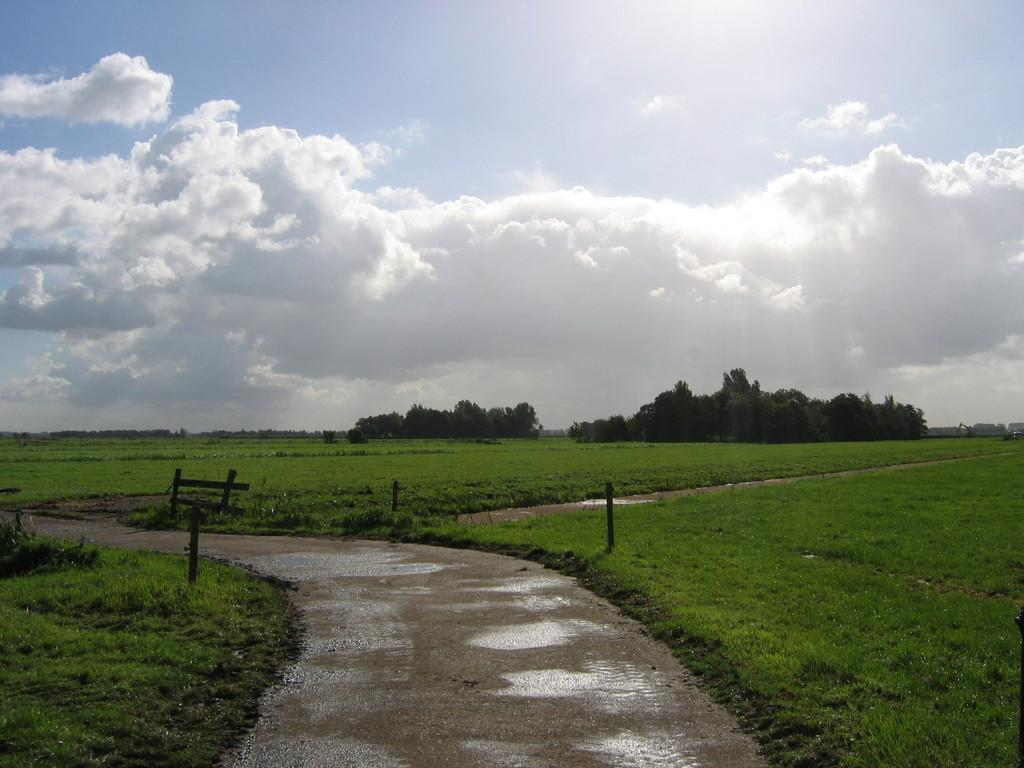What type of vegetation can be seen in the image? There are trees in the image. What structures are present in the image? There are wooden poles in the image. What is visible at the top of the image? The sky is visible at the top of the image. What can be seen in the sky? Clouds are present in the sky. What type of ground surface is visible at the bottom of the image? Grass is visible at the bottom of the image. What type of man-made surface is present in the image? There is a pavement in the image. Where is the earth located in the image? There is no specific location of "earth" in the image, as the term refers to the planet as a whole. However, the image shows a portion of the Earth's surface, including trees, grass, and a pavement. Can you see any icicles hanging from the trees in the image? There are no icicles present in the image; it appears to be a warm or temperate environment based on the presence of trees and grass. 